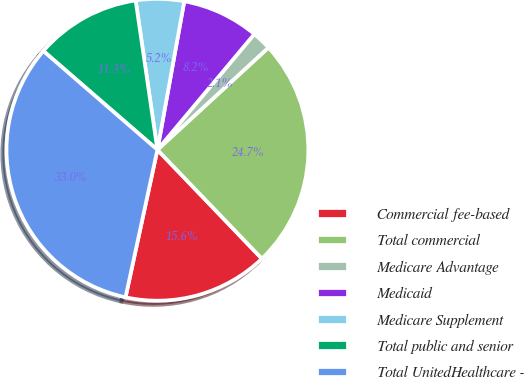Convert chart to OTSL. <chart><loc_0><loc_0><loc_500><loc_500><pie_chart><fcel>Commercial fee-based<fcel>Total commercial<fcel>Medicare Advantage<fcel>Medicaid<fcel>Medicare Supplement<fcel>Total public and senior<fcel>Total UnitedHealthcare -<nl><fcel>15.56%<fcel>24.67%<fcel>2.06%<fcel>8.25%<fcel>5.15%<fcel>11.34%<fcel>32.97%<nl></chart> 